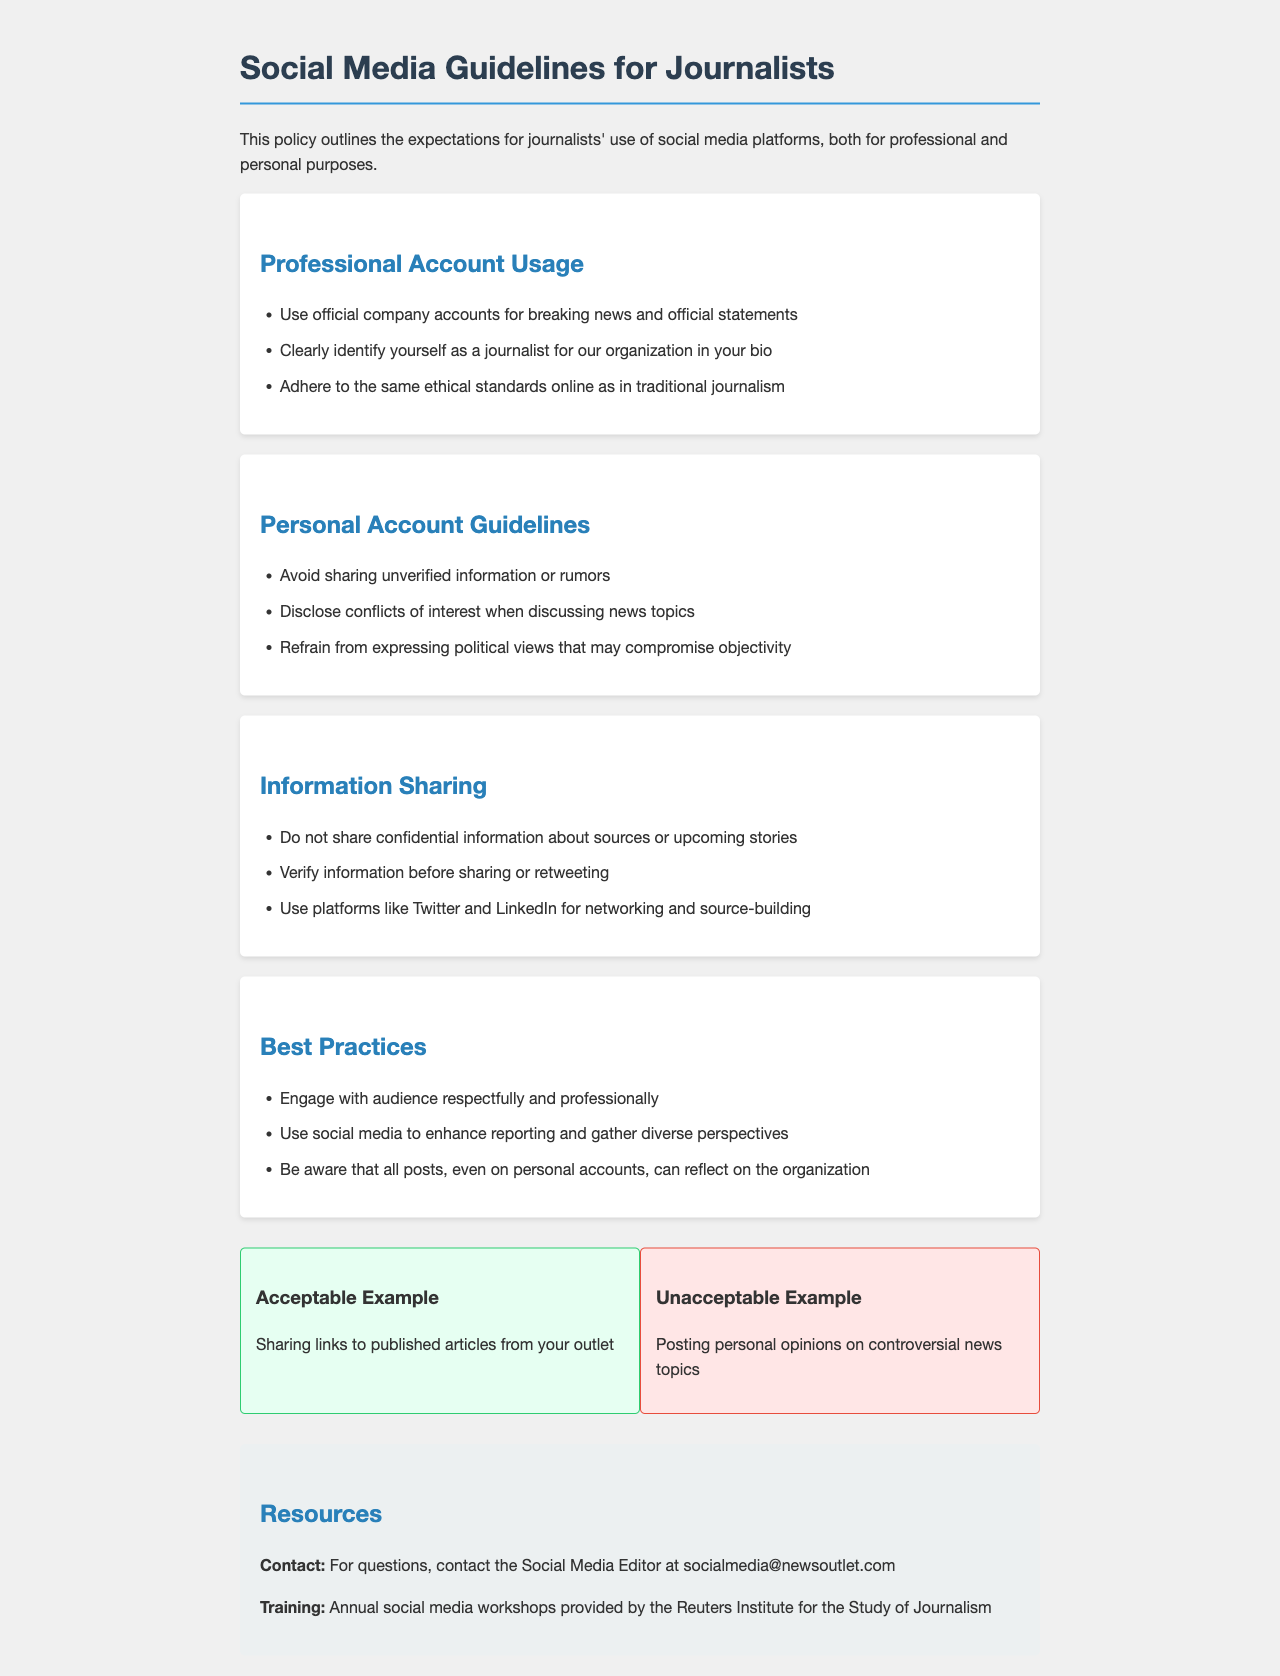What should journalists avoid sharing on personal accounts? The document states that journalists should avoid sharing unverified information or rumors.
Answer: Unverified information or rumors What are journalists required to disclose when discussing news topics? The guidelines mention that journalists must disclose conflicts of interest.
Answer: Conflicts of interest How should journalists identify themselves online? Journalists should clearly identify themselves as a journalist for their organization in their bio.
Answer: As a journalist for our organization What is the policy regarding sharing confidential information? The document states that journalists should not share confidential information about sources or upcoming stories.
Answer: Not share confidential information Name an acceptable example of social media usage for journalists. An acceptable example listed is sharing links to published articles from their outlet.
Answer: Sharing links to published articles What is the main purpose of using platforms like Twitter and LinkedIn? The document indicates that these platforms should be used for networking and source-building.
Answer: Networking and source-building What should journalists be aware of when posting on personal accounts? The policy reminds journalists that all posts can reflect on the organization.
Answer: All posts can reflect on the organization Who should journalists contact for questions regarding social media policy? The contact for questions is the Social Media Editor.
Answer: Social Media Editor What type of training is provided for journalists regarding social media? The document mentions annual social media workshops provided by the Reuters Institute for the Study of Journalism.
Answer: Annual social media workshops 